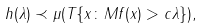<formula> <loc_0><loc_0><loc_500><loc_500>h ( \lambda ) \prec \mu ( T \{ x \colon M f ( x ) > c \lambda \} ) ,</formula> 